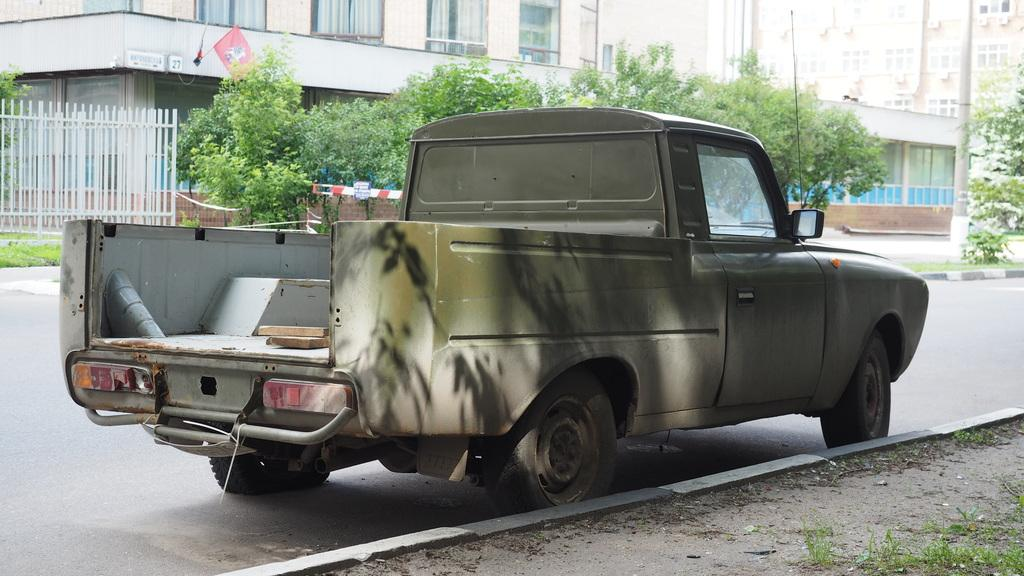What type of vehicle is on the road in the image? There is a mini truck on the road in the image. What structures can be seen in the image? There are buildings visible in the image. What type of vegetation is present in the image? There are trees in the image. What is attached to the building in the image? There is a flag on a building in the image. What type of barrier is present in the image? There is a metal fence in the image. What are the tall, thin objects in the image? There are poles in the image. How does the dust settle on the page in the image? There is no page or dust present in the image. 